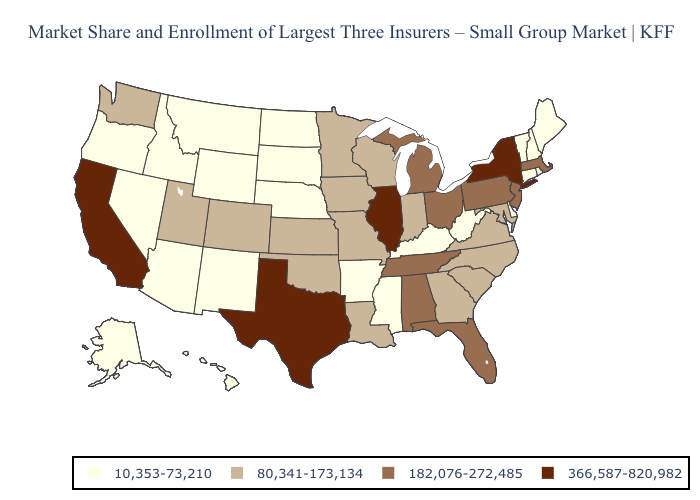What is the lowest value in the USA?
Give a very brief answer. 10,353-73,210. What is the value of Washington?
Short answer required. 80,341-173,134. Does Indiana have the lowest value in the MidWest?
Keep it brief. No. Name the states that have a value in the range 182,076-272,485?
Answer briefly. Alabama, Florida, Massachusetts, Michigan, New Jersey, Ohio, Pennsylvania, Tennessee. Does Utah have the lowest value in the West?
Give a very brief answer. No. Which states have the lowest value in the USA?
Keep it brief. Alaska, Arizona, Arkansas, Connecticut, Delaware, Hawaii, Idaho, Kentucky, Maine, Mississippi, Montana, Nebraska, Nevada, New Hampshire, New Mexico, North Dakota, Oregon, Rhode Island, South Dakota, Vermont, West Virginia, Wyoming. Name the states that have a value in the range 366,587-820,982?
Quick response, please. California, Illinois, New York, Texas. Does Arkansas have the lowest value in the USA?
Concise answer only. Yes. Does the map have missing data?
Be succinct. No. Name the states that have a value in the range 182,076-272,485?
Give a very brief answer. Alabama, Florida, Massachusetts, Michigan, New Jersey, Ohio, Pennsylvania, Tennessee. Does Kentucky have the highest value in the USA?
Short answer required. No. Is the legend a continuous bar?
Keep it brief. No. Name the states that have a value in the range 80,341-173,134?
Concise answer only. Colorado, Georgia, Indiana, Iowa, Kansas, Louisiana, Maryland, Minnesota, Missouri, North Carolina, Oklahoma, South Carolina, Utah, Virginia, Washington, Wisconsin. Name the states that have a value in the range 10,353-73,210?
Concise answer only. Alaska, Arizona, Arkansas, Connecticut, Delaware, Hawaii, Idaho, Kentucky, Maine, Mississippi, Montana, Nebraska, Nevada, New Hampshire, New Mexico, North Dakota, Oregon, Rhode Island, South Dakota, Vermont, West Virginia, Wyoming. 